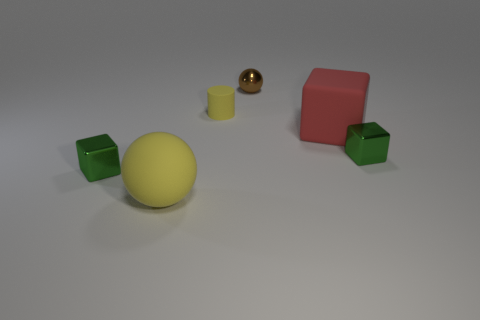There is a sphere that is to the right of the matte sphere; does it have the same size as the yellow matte cylinder?
Your response must be concise. Yes. How many matte objects are either big yellow objects or large red cubes?
Offer a terse response. 2. How big is the yellow object that is to the left of the cylinder?
Your response must be concise. Large. Does the red thing have the same shape as the brown thing?
Keep it short and to the point. No. What number of tiny objects are either yellow matte objects or metal things?
Your answer should be compact. 4. Are there any cylinders behind the brown ball?
Your answer should be very brief. No. Is the number of rubber spheres that are in front of the small yellow object the same as the number of cubes?
Give a very brief answer. No. What size is the brown object that is the same shape as the big yellow matte object?
Keep it short and to the point. Small. There is a big red object; is its shape the same as the green metal thing that is to the right of the small yellow cylinder?
Your answer should be very brief. Yes. There is a green metallic cube that is on the left side of the big yellow sphere in front of the metal sphere; what is its size?
Your answer should be compact. Small. 